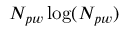<formula> <loc_0><loc_0><loc_500><loc_500>N _ { p w } \log ( N _ { p w } )</formula> 